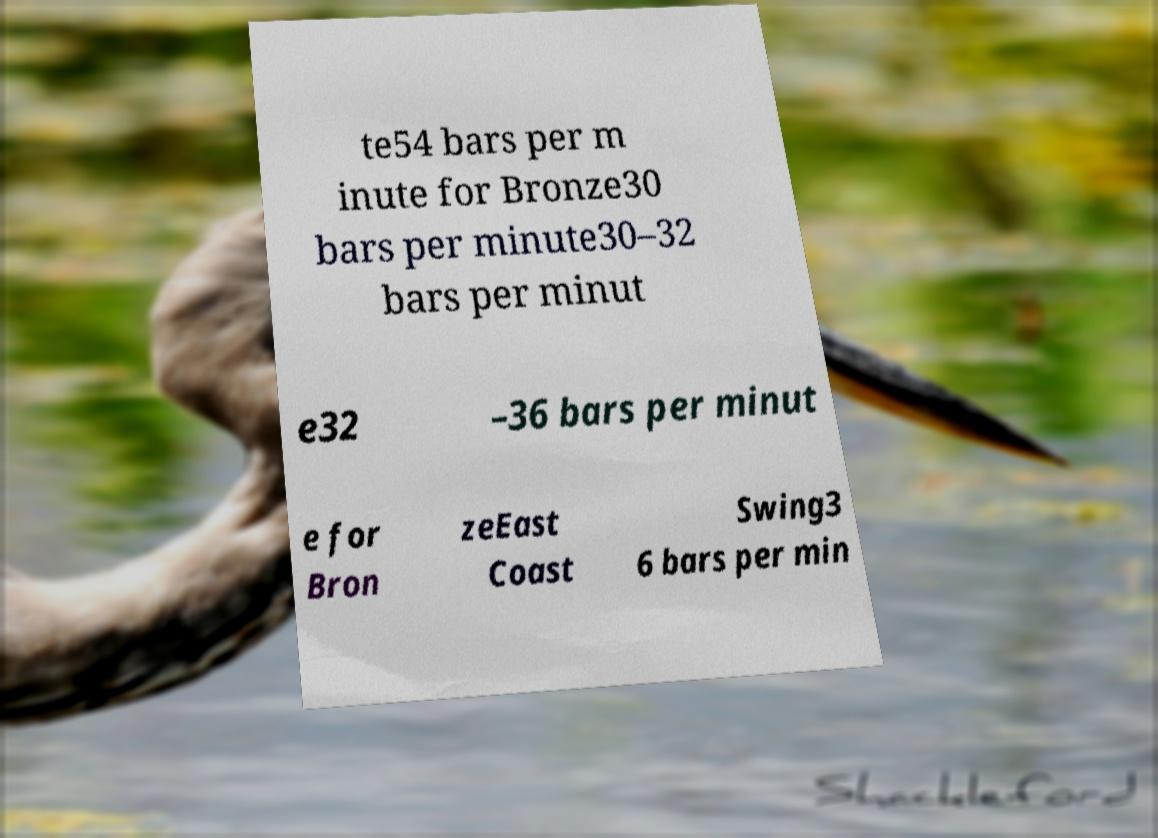Could you assist in decoding the text presented in this image and type it out clearly? te54 bars per m inute for Bronze30 bars per minute30–32 bars per minut e32 –36 bars per minut e for Bron zeEast Coast Swing3 6 bars per min 